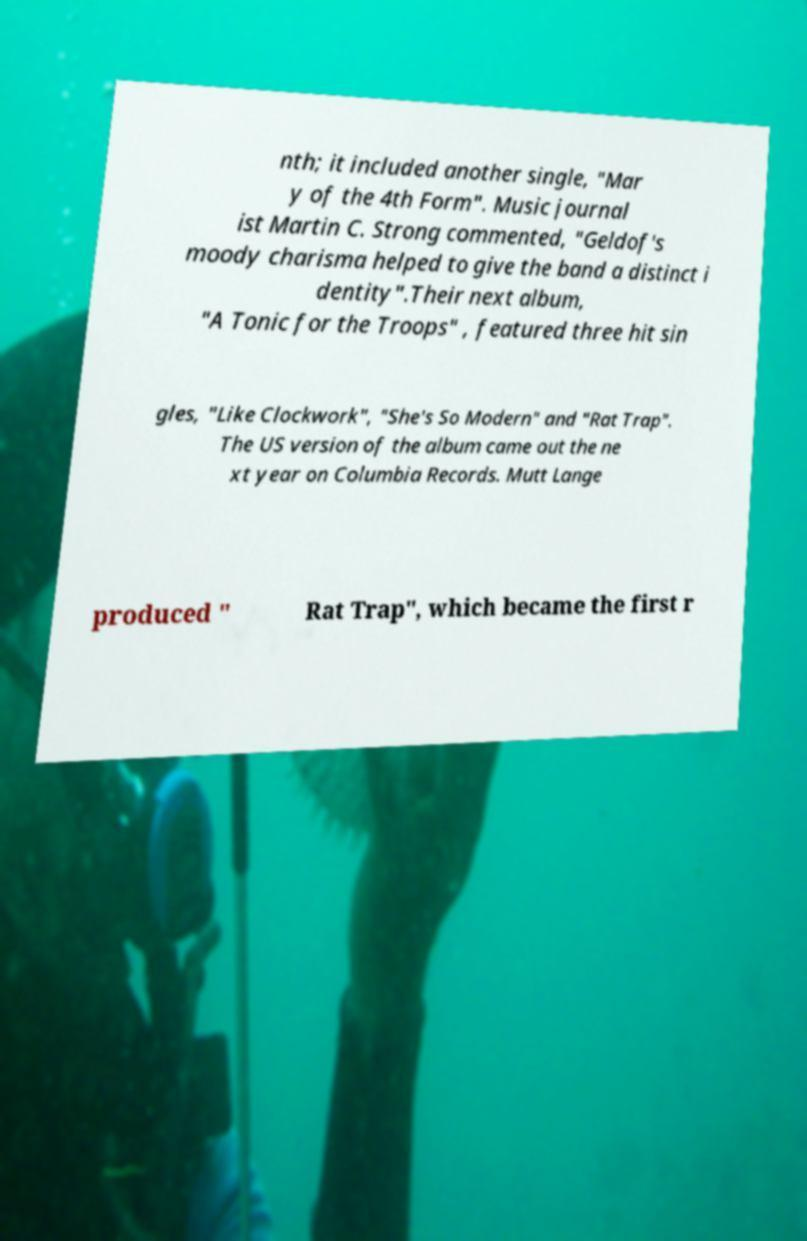For documentation purposes, I need the text within this image transcribed. Could you provide that? nth; it included another single, "Mar y of the 4th Form". Music journal ist Martin C. Strong commented, "Geldof's moody charisma helped to give the band a distinct i dentity".Their next album, "A Tonic for the Troops" , featured three hit sin gles, "Like Clockwork", "She's So Modern" and "Rat Trap". The US version of the album came out the ne xt year on Columbia Records. Mutt Lange produced " Rat Trap", which became the first r 